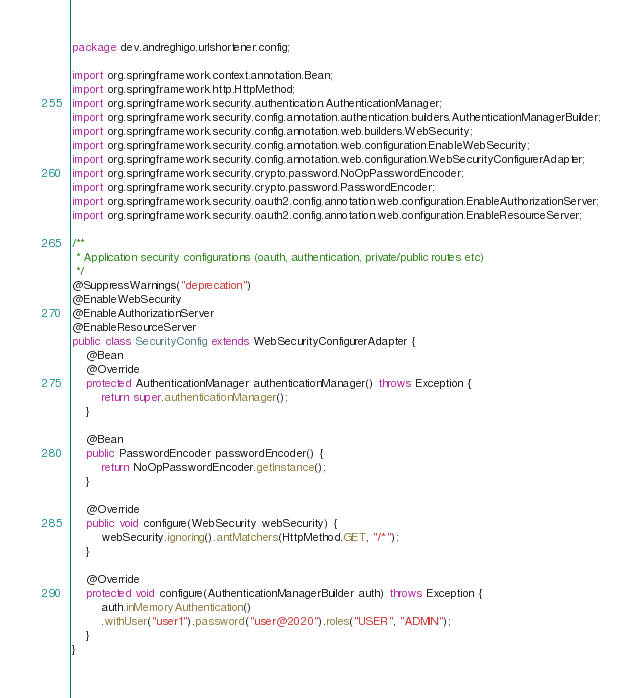<code> <loc_0><loc_0><loc_500><loc_500><_Java_>package dev.andreghigo.urlshortener.config;

import org.springframework.context.annotation.Bean;
import org.springframework.http.HttpMethod;
import org.springframework.security.authentication.AuthenticationManager;
import org.springframework.security.config.annotation.authentication.builders.AuthenticationManagerBuilder;
import org.springframework.security.config.annotation.web.builders.WebSecurity;
import org.springframework.security.config.annotation.web.configuration.EnableWebSecurity;
import org.springframework.security.config.annotation.web.configuration.WebSecurityConfigurerAdapter;
import org.springframework.security.crypto.password.NoOpPasswordEncoder;
import org.springframework.security.crypto.password.PasswordEncoder;
import org.springframework.security.oauth2.config.annotation.web.configuration.EnableAuthorizationServer;
import org.springframework.security.oauth2.config.annotation.web.configuration.EnableResourceServer;

/**
 * Application security configurations (oauth, authentication, private/public routes etc)
 */
@SuppressWarnings("deprecation")
@EnableWebSecurity
@EnableAuthorizationServer
@EnableResourceServer
public class SecurityConfig extends WebSecurityConfigurerAdapter {
	@Bean
	@Override
	protected AuthenticationManager authenticationManager() throws Exception {
		return super.authenticationManager();
	}

	@Bean
	public PasswordEncoder passwordEncoder() {
		return NoOpPasswordEncoder.getInstance();
	}
	
	@Override
	public void configure(WebSecurity webSecurity) {
	    webSecurity.ignoring().antMatchers(HttpMethod.GET, "/*");
	}	

	@Override
	protected void configure(AuthenticationManagerBuilder auth) throws Exception {
		auth.inMemoryAuthentication()
		.withUser("user1").password("user@2020").roles("USER", "ADMIN");
	}
}
</code> 